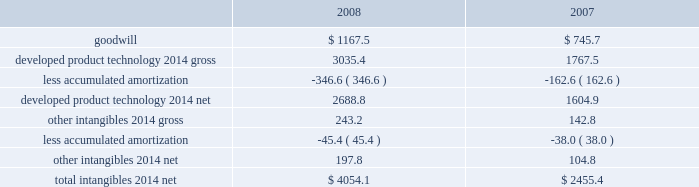On the underlying exposure .
For derivative contracts that are designated and qualify as cash fl ow hedges , the effective portion of gains and losses on these contracts is reported as a component of other comprehensive income and reclassifi ed into earnings in the same period the hedged transaction affects earnings .
Hedge ineffectiveness is immediately recognized in earnings .
Derivative contracts that are not designated as hedging instruments are recorded at fair value with the gain or loss recognized in current earnings during the period of change .
We may enter into foreign currency forward and option contracts to reduce the effect of fl uctuating currency exchange rates ( principally the euro , the british pound , and the japanese yen ) .
Foreign currency derivatives used for hedging are put in place using the same or like currencies and duration as the underlying exposures .
Forward contracts are principally used to manage exposures arising from subsidiary trade and loan payables and receivables denominated in foreign currencies .
These contracts are recorded at fair value with the gain or loss recognized in other 2014net .
The purchased option contracts are used to hedge anticipated foreign currency transactions , primarily intercompany inventory activities expected to occur within the next year .
These contracts are designated as cash fl ow hedges of those future transactions and the impact on earnings is included in cost of sales .
We may enter into foreign currency forward contracts and currency swaps as fair value hedges of fi rm commitments .
Forward and option contracts generally have maturities not exceeding 12 months .
In the normal course of business , our operations are exposed to fl uctuations in interest rates .
These fl uctuations can vary the costs of fi nancing , investing , and operating .
We address a portion of these risks through a controlled program of risk management that includes the use of derivative fi nancial instruments .
The objective of controlling these risks is to limit the impact of fl uctuations in interest rates on earnings .
Our primary interest rate risk exposure results from changes in short-term u.s .
Dollar interest rates .
In an effort to manage interest rate exposures , we strive to achieve an acceptable balance between fi xed and fl oating rate debt and investment positions and may enter into interest rate swaps or collars to help maintain that balance .
Interest rate swaps or collars that convert our fi xed- rate debt or investments to a fl oating rate are designated as fair value hedges of the underlying instruments .
Interest rate swaps or collars that convert fl oating rate debt or investments to a fi xed rate are designated as cash fl ow hedg- es .
Interest expense on the debt is adjusted to include the payments made or received under the swap agreements .
Goodwill and other intangibles : goodwill is not amortized .
All other intangibles arising from acquisitions and research alliances have fi nite lives and are amortized over their estimated useful lives , ranging from 5 to 20 years , using the straight-line method .
The weighted-average amortization period for developed product technology is approximately 12 years .
Amortization expense for 2008 , 2007 , and 2006 was $ 193.4 million , $ 172.8 million , and $ 7.6 million before tax , respectively .
The estimated amortization expense for each of the fi ve succeeding years approximates $ 280 million before tax , per year .
Substantially all of the amortization expense is included in cost of sales .
See note 3 for further discussion of goodwill and other intangibles acquired in 2008 and 2007 .
Goodwill and other intangible assets at december 31 were as follows: .
Goodwill and net other intangibles are reviewed to assess recoverability at least annually and when certain impairment indicators are present .
No signifi cant impairments occurred with respect to the carrying value of our goodwill or other intangible assets in 2008 , 2007 , or 2006 .
Property and equipment : property and equipment is stated on the basis of cost .
Provisions for depreciation of buildings and equipment are computed generally by the straight-line method at rates based on their estimated useful lives ( 12 to 50 years for buildings and 3 to 18 years for equipment ) .
We review the carrying value of long-lived assets for potential impairment on a periodic basis and whenever events or changes in circumstances indicate the .
What percentage of total intangibles-net in 2007 were comprised of developed product technology-gross? 
Computations: (1767.5 / 2455.4)
Answer: 0.71984. 